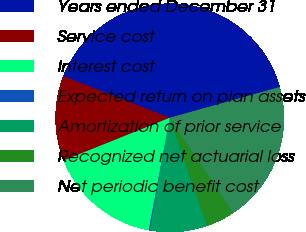Convert chart. <chart><loc_0><loc_0><loc_500><loc_500><pie_chart><fcel>Years ended December 31<fcel>Service cost<fcel>Interest cost<fcel>Expected return on plan assets<fcel>Amortization of prior service<fcel>Recognized net actuarial loss<fcel>Net periodic benefit cost<nl><fcel>39.72%<fcel>12.03%<fcel>15.98%<fcel>0.16%<fcel>8.07%<fcel>4.11%<fcel>19.94%<nl></chart> 